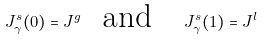<formula> <loc_0><loc_0><loc_500><loc_500>J _ { \gamma } ^ { s } ( 0 ) = J ^ { g } \text {\ \ and\quad } J _ { \gamma } ^ { s } ( 1 ) = J ^ { l }</formula> 